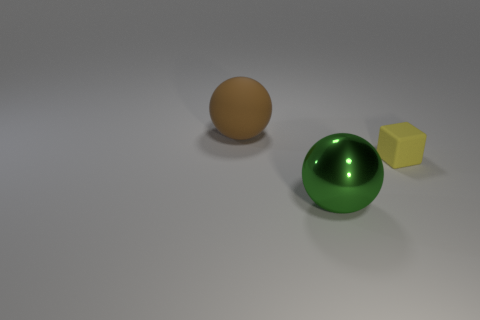Add 2 big yellow matte cylinders. How many objects exist? 5 Subtract all spheres. How many objects are left? 1 Subtract all cyan metallic cylinders. Subtract all rubber spheres. How many objects are left? 2 Add 1 big green metallic balls. How many big green metallic balls are left? 2 Add 1 big brown rubber objects. How many big brown rubber objects exist? 2 Subtract 0 cyan blocks. How many objects are left? 3 